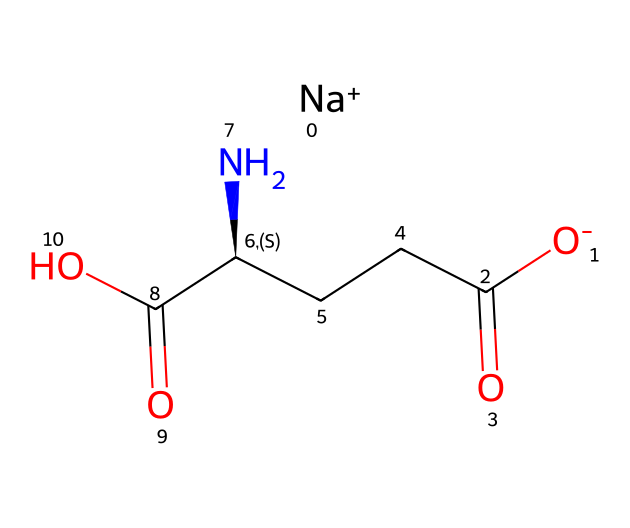What is the common name of this chemical? The chemical structure represents monosodium glutamate, commonly used as a flavor enhancer in foods. The name can be derived from its structural components, which include sodium and glutamate.
Answer: monosodium glutamate How many carbon atoms are present in this chemical? By analyzing the SMILES representation, we can count the carbon atoms. The structure shows a total of five carbon atoms (C), indicated in the backbone.
Answer: five What type of functional group is present in this chemical? Looking at the SMILES structure, we see the presence of carboxylic acid functional groups (-COOH). These groups are characteristic of acidic properties in the compound.
Answer: carboxylic acid How many nitrogen atoms are in the structure? From the SMILES notation, there is one nitrogen atom (N) visible, which is part of the amino group (-NH2) that indicates its nature as an amino acid derivative.
Answer: one What does the presence of sodium ion imply about this chemical? The presence of [Na+] in the SMILES structure indicates that this compound is a sodium salt of glutamate, suggesting that it enhances solubility in water and is safe for consumption.
Answer: sodium salt What structural feature implies that this is a flavor enhancer? The combination of amino acid groups and the sodium component suggest a savory flavor profile, as such structures are often associated with umami taste, a key characteristic of flavor enhancers.
Answer: savory flavor profile 